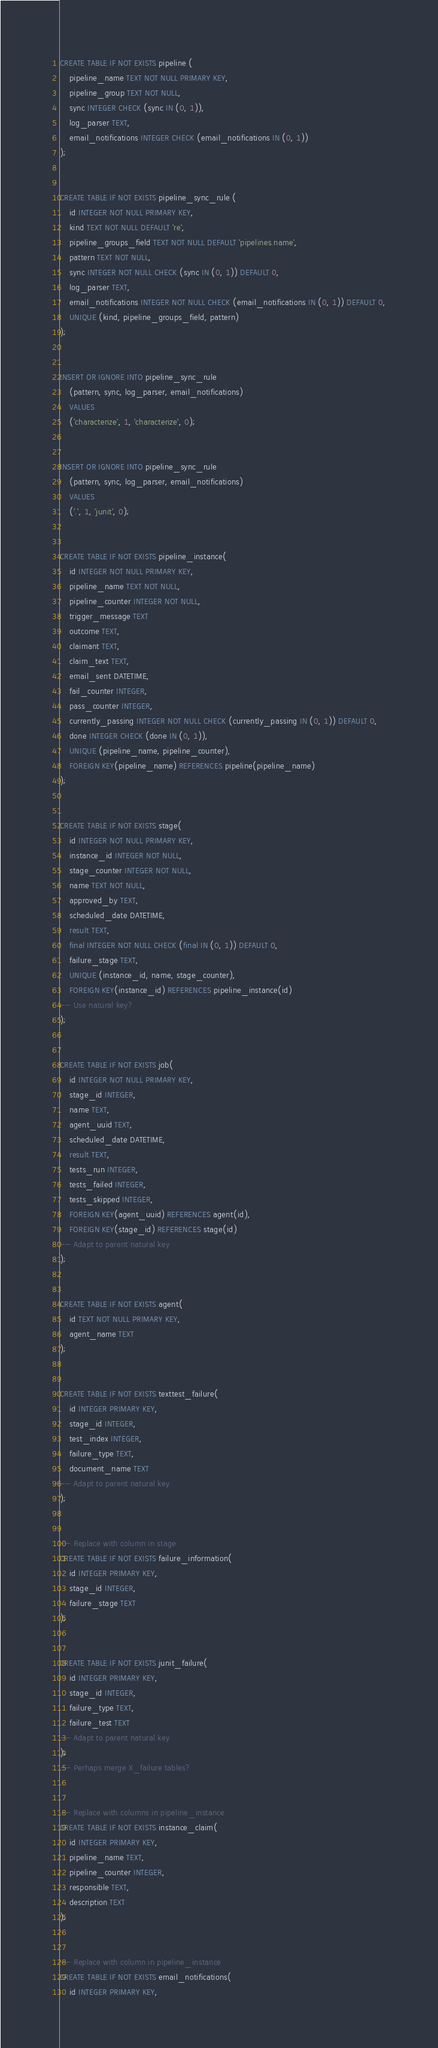<code> <loc_0><loc_0><loc_500><loc_500><_SQL_>CREATE TABLE IF NOT EXISTS pipeline (
    pipeline_name TEXT NOT NULL PRIMARY KEY,
    pipeline_group TEXT NOT NULL,
    sync INTEGER CHECK (sync IN (0, 1)),
    log_parser TEXT,
    email_notifications INTEGER CHECK (email_notifications IN (0, 1))
);


CREATE TABLE IF NOT EXISTS pipeline_sync_rule (
    id INTEGER NOT NULL PRIMARY KEY,
    kind TEXT NOT NULL DEFAULT 're',
    pipeline_groups_field TEXT NOT NULL DEFAULT 'pipelines.name',
    pattern TEXT NOT NULL,
    sync INTEGER NOT NULL CHECK (sync IN (0, 1)) DEFAULT 0,
    log_parser TEXT,
    email_notifications INTEGER NOT NULL CHECK (email_notifications IN (0, 1)) DEFAULT 0,
    UNIQUE (kind, pipeline_groups_field, pattern)
);


INSERT OR IGNORE INTO pipeline_sync_rule
    (pattern, sync, log_parser, email_notifications)
    VALUES
    ('characterize', 1, 'characterize', 0);


INSERT OR IGNORE INTO pipeline_sync_rule
    (pattern, sync, log_parser, email_notifications)
    VALUES
    ('.', 1, 'junit', 0);


CREATE TABLE IF NOT EXISTS pipeline_instance(
    id INTEGER NOT NULL PRIMARY KEY,
    pipeline_name TEXT NOT NULL,
    pipeline_counter INTEGER NOT NULL,
    trigger_message TEXT
    outcome TEXT,
    claimant TEXT,
    claim_text TEXT,
    email_sent DATETIME,
    fail_counter INTEGER,
    pass_counter INTEGER,
    currently_passing INTEGER NOT NULL CHECK (currently_passing IN (0, 1)) DEFAULT 0,
    done INTEGER CHECK (done IN (0, 1)),
    UNIQUE (pipeline_name, pipeline_counter),
    FOREIGN KEY(pipeline_name) REFERENCES pipeline(pipeline_name)
);


CREATE TABLE IF NOT EXISTS stage(
    id INTEGER NOT NULL PRIMARY KEY,
    instance_id INTEGER NOT NULL,
    stage_counter INTEGER NOT NULL,
    name TEXT NOT NULL,
    approved_by TEXT,
    scheduled_date DATETIME,
    result TEXT,
    final INTEGER NOT NULL CHECK (final IN (0, 1)) DEFAULT 0,
    failure_stage TEXT,
    UNIQUE (instance_id, name, stage_counter),
    FOREIGN KEY(instance_id) REFERENCES pipeline_instance(id)
-- Use natural key?
);


CREATE TABLE IF NOT EXISTS job(
    id INTEGER NOT NULL PRIMARY KEY,
    stage_id INTEGER,
    name TEXT,
    agent_uuid TEXT,
    scheduled_date DATETIME,
    result TEXT,
    tests_run INTEGER,
    tests_failed INTEGER,
    tests_skipped INTEGER,
    FOREIGN KEY(agent_uuid) REFERENCES agent(id),
    FOREIGN KEY(stage_id) REFERENCES stage(id)
-- Adapt to parent natural key
);


CREATE TABLE IF NOT EXISTS agent(
    id TEXT NOT NULL PRIMARY KEY,
    agent_name TEXT
);


CREATE TABLE IF NOT EXISTS texttest_failure(
    id INTEGER PRIMARY KEY,
    stage_id INTEGER,
    test_index INTEGER,
    failure_type TEXT,
    document_name TEXT
-- Adapt to parent natural key
);


-- Replace with column in stage
CREATE TABLE IF NOT EXISTS failure_information(
    id INTEGER PRIMARY KEY,
    stage_id INTEGER,
    failure_stage TEXT
);


CREATE TABLE IF NOT EXISTS junit_failure(
    id INTEGER PRIMARY KEY,
    stage_id INTEGER,
    failure_type TEXT,
    failure_test TEXT
-- Adapt to parent natural key
);
-- Perhaps merge X_failure tables?


-- Replace with columns in pipeline_instance
CREATE TABLE IF NOT EXISTS instance_claim(
    id INTEGER PRIMARY KEY,
    pipeline_name TEXT,
    pipeline_counter INTEGER,
    responsible TEXT,
    description TEXT
);


-- Replace with column in pipeline_instance
CREATE TABLE IF NOT EXISTS email_notifications(
    id INTEGER PRIMARY KEY,</code> 